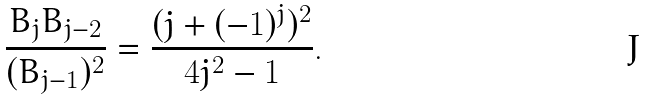Convert formula to latex. <formula><loc_0><loc_0><loc_500><loc_500>\frac { B _ { j } B _ { j - 2 } } { ( B _ { j - 1 } ) ^ { 2 } } = \frac { ( j + ( - 1 ) ^ { j } ) ^ { 2 } } { 4 j ^ { 2 } - 1 } .</formula> 